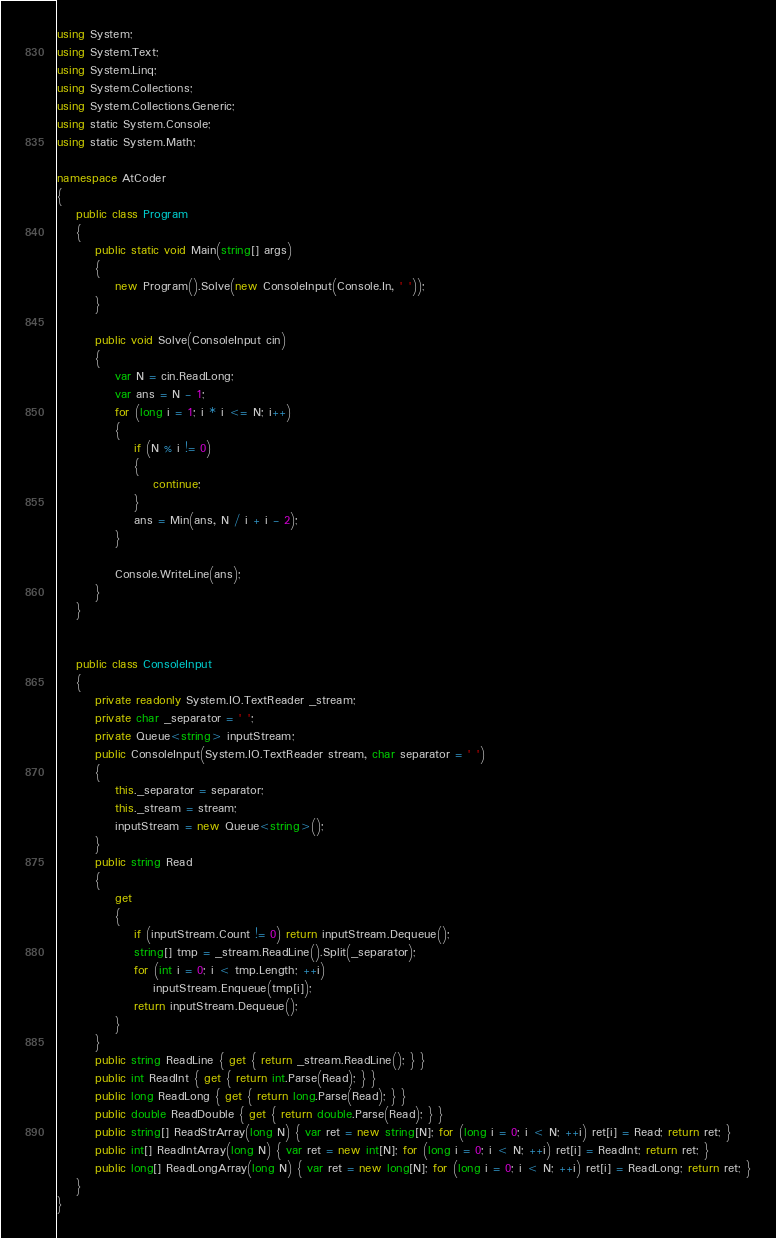<code> <loc_0><loc_0><loc_500><loc_500><_C#_>using System;
using System.Text;
using System.Linq;
using System.Collections;
using System.Collections.Generic;
using static System.Console;
using static System.Math;

namespace AtCoder
{
    public class Program
    {
        public static void Main(string[] args)
        {
            new Program().Solve(new ConsoleInput(Console.In, ' '));
        }

        public void Solve(ConsoleInput cin)
        {
            var N = cin.ReadLong;
            var ans = N - 1;
            for (long i = 1; i * i <= N; i++)
            {
                if (N % i != 0)
                {
                    continue;
                }
                ans = Min(ans, N / i + i - 2);
            }

            Console.WriteLine(ans);
        }
    }


    public class ConsoleInput
    {
        private readonly System.IO.TextReader _stream;
        private char _separator = ' ';
        private Queue<string> inputStream;
        public ConsoleInput(System.IO.TextReader stream, char separator = ' ')
        {
            this._separator = separator;
            this._stream = stream;
            inputStream = new Queue<string>();
        }
        public string Read
        {
            get
            {
                if (inputStream.Count != 0) return inputStream.Dequeue();
                string[] tmp = _stream.ReadLine().Split(_separator);
                for (int i = 0; i < tmp.Length; ++i)
                    inputStream.Enqueue(tmp[i]);
                return inputStream.Dequeue();
            }
        }
        public string ReadLine { get { return _stream.ReadLine(); } }
        public int ReadInt { get { return int.Parse(Read); } }
        public long ReadLong { get { return long.Parse(Read); } }
        public double ReadDouble { get { return double.Parse(Read); } }
        public string[] ReadStrArray(long N) { var ret = new string[N]; for (long i = 0; i < N; ++i) ret[i] = Read; return ret; }
        public int[] ReadIntArray(long N) { var ret = new int[N]; for (long i = 0; i < N; ++i) ret[i] = ReadInt; return ret; }
        public long[] ReadLongArray(long N) { var ret = new long[N]; for (long i = 0; i < N; ++i) ret[i] = ReadLong; return ret; }
    }
}</code> 